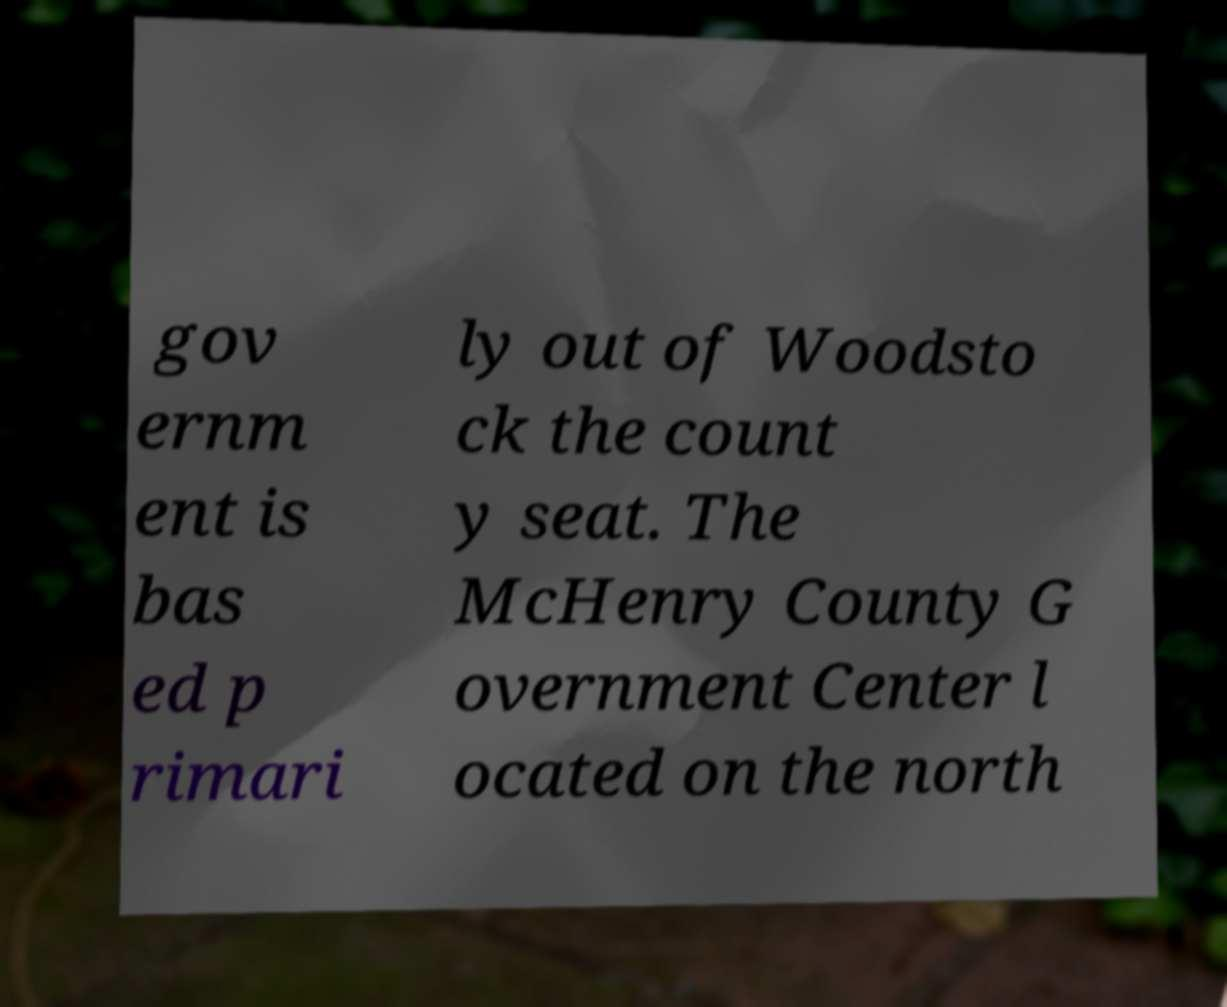Can you read and provide the text displayed in the image?This photo seems to have some interesting text. Can you extract and type it out for me? gov ernm ent is bas ed p rimari ly out of Woodsto ck the count y seat. The McHenry County G overnment Center l ocated on the north 